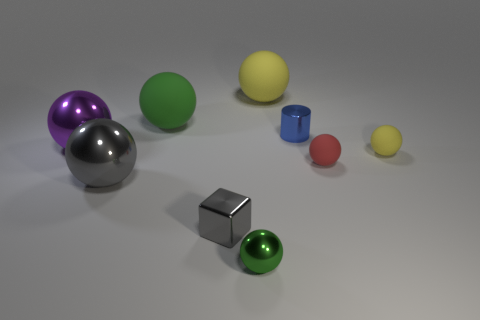Subtract all gray spheres. How many spheres are left? 6 Subtract all green spheres. How many spheres are left? 5 Subtract all gray balls. Subtract all yellow blocks. How many balls are left? 6 Add 1 large gray metallic balls. How many objects exist? 10 Subtract all balls. How many objects are left? 2 Subtract 1 gray balls. How many objects are left? 8 Subtract all large green metallic blocks. Subtract all large yellow rubber things. How many objects are left? 8 Add 6 matte balls. How many matte balls are left? 10 Add 7 cyan rubber blocks. How many cyan rubber blocks exist? 7 